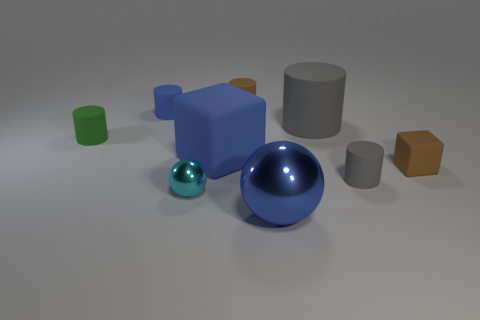Does the large thing that is in front of the cyan thing have the same color as the large block?
Make the answer very short. Yes. There is a tiny brown rubber object on the right side of the tiny brown object behind the blue matte cylinder; what number of tiny brown objects are behind it?
Keep it short and to the point. 1. There is a tiny green thing; what number of cylinders are right of it?
Your answer should be very brief. 4. There is another small shiny thing that is the same shape as the blue metallic object; what is its color?
Give a very brief answer. Cyan. What material is the large object that is both behind the tiny cyan thing and to the right of the big cube?
Provide a succinct answer. Rubber. Does the brown matte object that is behind the brown cube have the same size as the tiny shiny sphere?
Your answer should be compact. Yes. What material is the large blue sphere?
Make the answer very short. Metal. The matte cube right of the big metal thing is what color?
Offer a very short reply. Brown. How many tiny things are either cylinders or purple cylinders?
Ensure brevity in your answer.  4. There is a small rubber object that is on the right side of the tiny gray rubber object; is it the same color as the matte cylinder that is behind the small blue object?
Keep it short and to the point. Yes. 